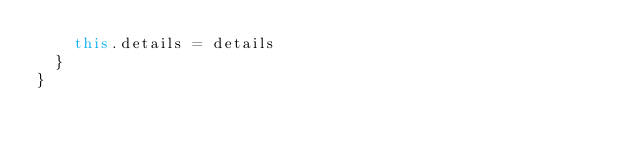Convert code to text. <code><loc_0><loc_0><loc_500><loc_500><_JavaScript_>    this.details = details
  }
}
</code> 